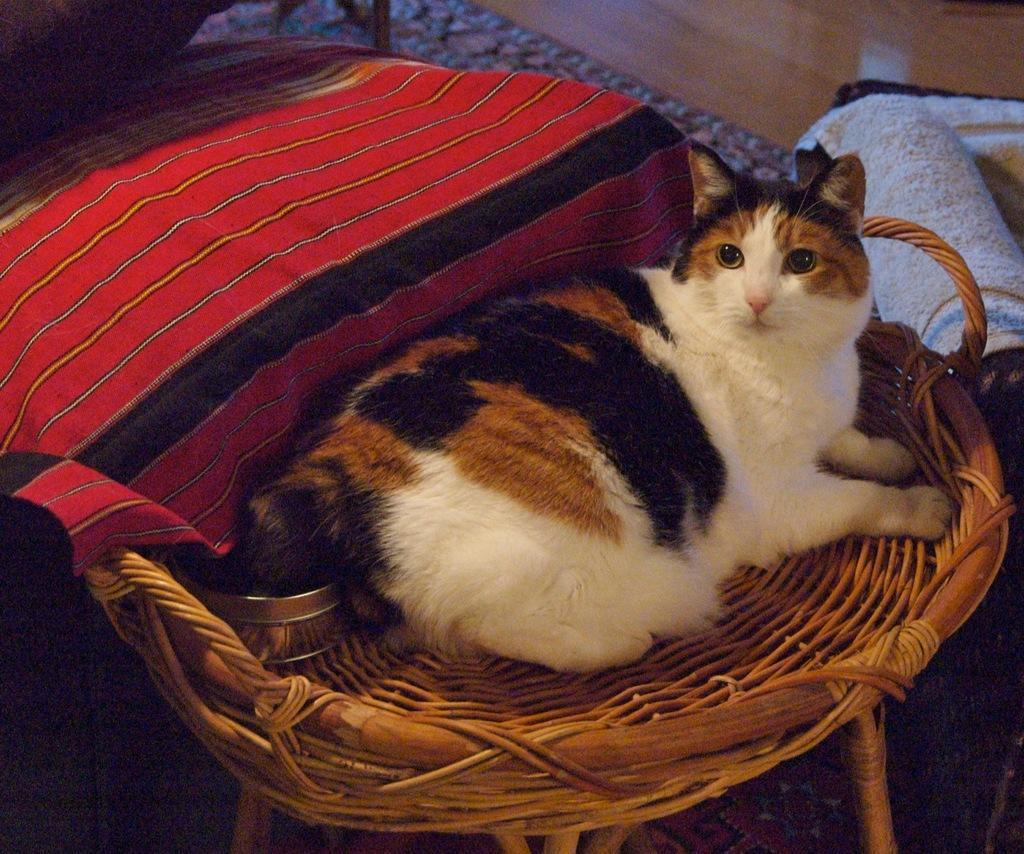Can you describe this image briefly? In the picture I can see a cat is sitting on a wooden object. Here I can see clothes and some other objects on the floor. 